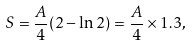Convert formula to latex. <formula><loc_0><loc_0><loc_500><loc_500>S = \frac { A } { 4 } ( 2 - \ln 2 ) = \frac { A } { 4 } \times 1 . 3 ,</formula> 